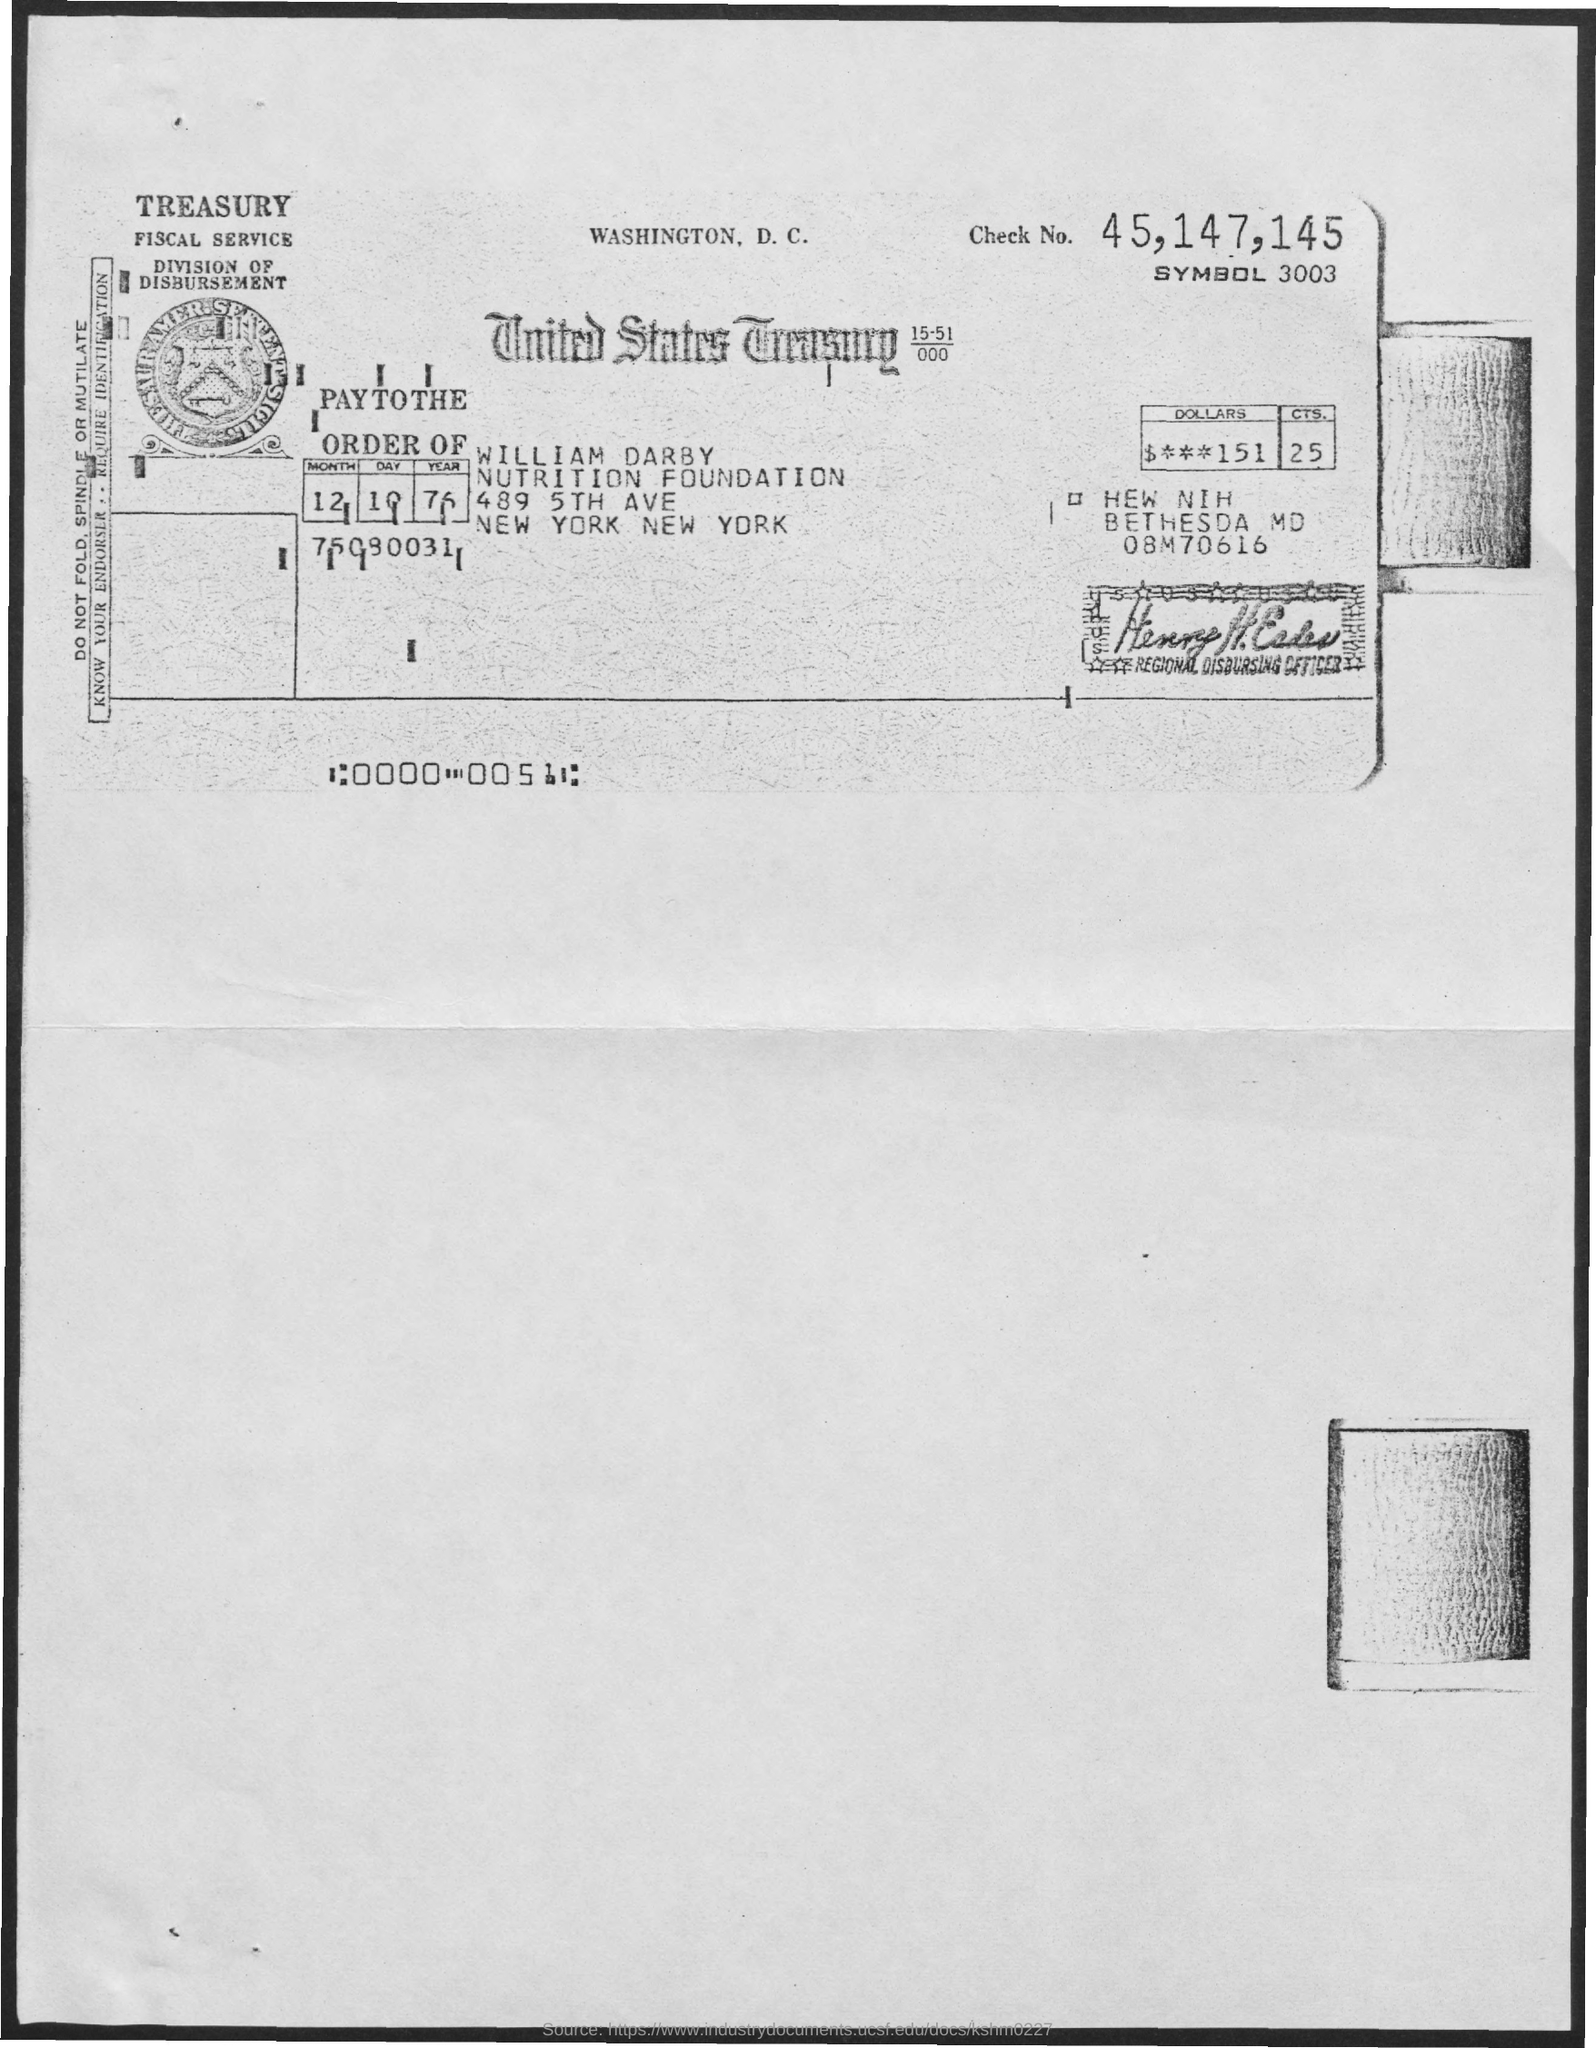What is the check no. mentioned ?
Make the answer very short. 45,147,145. What  is the name of the division ?
Your answer should be very brief. Division of disbursement. What is the amount of dollars mentioned?
Provide a succinct answer. 151. What is the amount of cents mentioned ?
Your answer should be very brief. 25. What is the date mentioned ?
Keep it short and to the point. 12 10 76. What is the name mentioned for pay to the order of ?
Make the answer very short. William darby. What is the name of the foundation mentioned ?
Provide a short and direct response. Nutrition foundation. What is the symbol no. mentioned ?
Keep it short and to the point. 3003. 